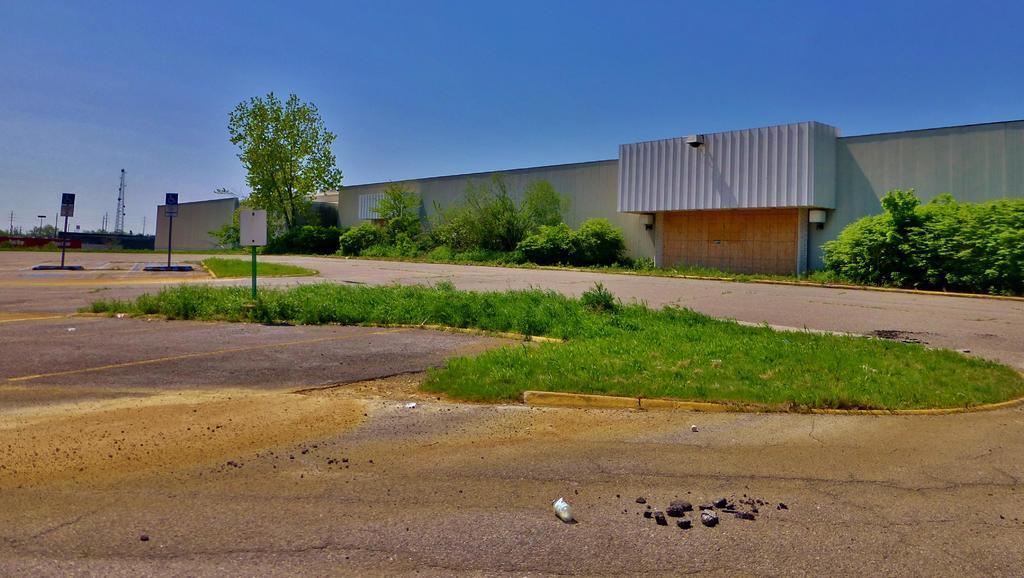Describe this image in one or two sentences. This is an outside view. At the bottom of the image I can see the road. Beside the road there is grass. On the left side, I can see few poles. In the background there is a shed and some trees also I can see a transmission pole. On the top of the image I can see the sky. 